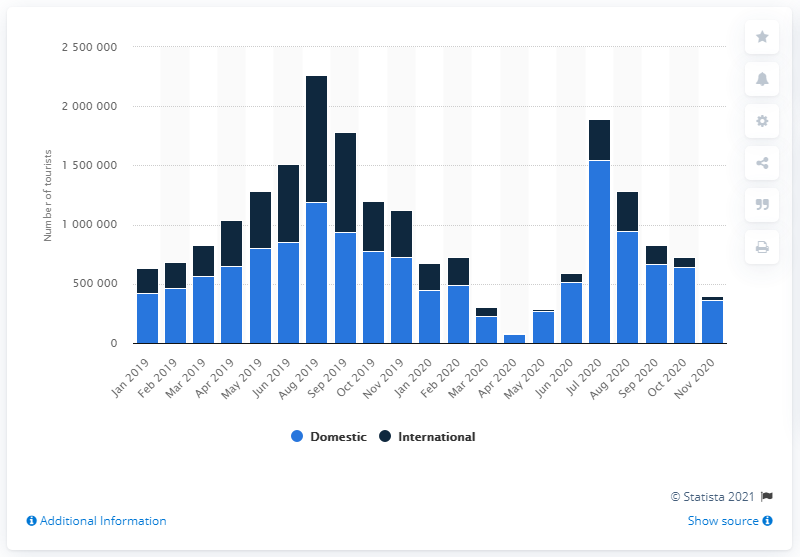Identify some key points in this picture. In April 2019, there were 652,883 domestic visitors in Denmark. In April 2020, there were 79,962 tourists in Denmark. 